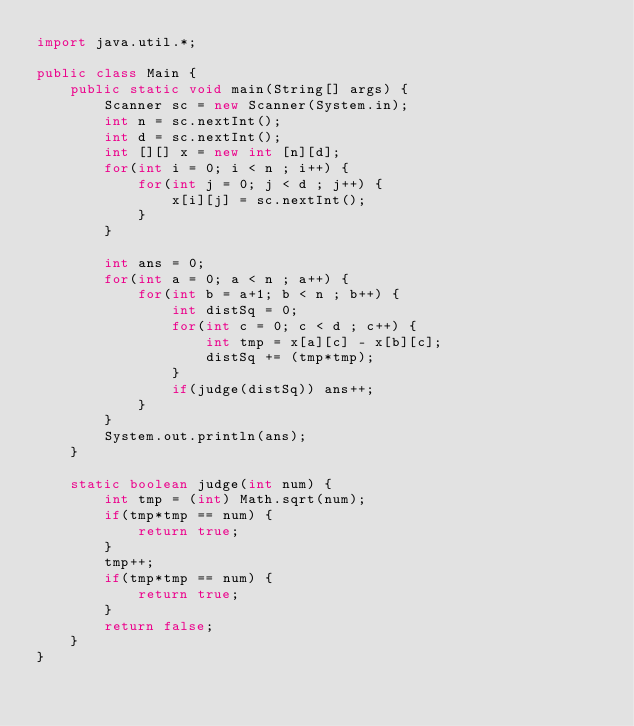<code> <loc_0><loc_0><loc_500><loc_500><_Java_>import java.util.*;

public class Main {
    public static void main(String[] args) {
        Scanner sc = new Scanner(System.in);
        int n = sc.nextInt();
        int d = sc.nextInt();
        int [][] x = new int [n][d];
        for(int i = 0; i < n ; i++) {
            for(int j = 0; j < d ; j++) {
                x[i][j] = sc.nextInt();
            }
        }
        
        int ans = 0;
        for(int a = 0; a < n ; a++) {
            for(int b = a+1; b < n ; b++) {
                int distSq = 0;
                for(int c = 0; c < d ; c++) {
                    int tmp = x[a][c] - x[b][c];
                    distSq += (tmp*tmp);
                }
                if(judge(distSq)) ans++;
            }
        }
        System.out.println(ans);
    }
    
    static boolean judge(int num) {
        int tmp = (int) Math.sqrt(num);
        if(tmp*tmp == num) {
            return true;
        }
        tmp++;
        if(tmp*tmp == num) {
            return true;
        }
        return false;
    }
}</code> 